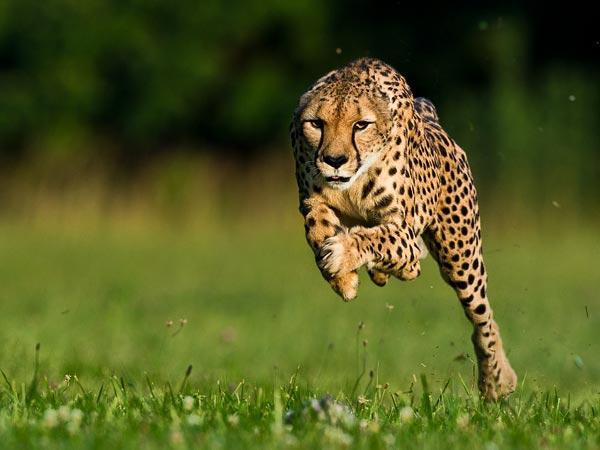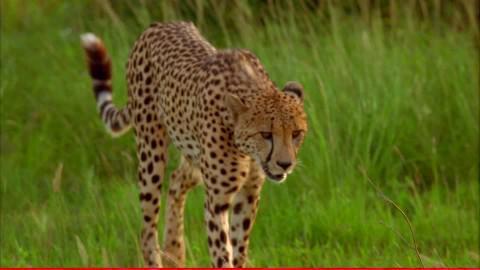The first image is the image on the left, the second image is the image on the right. For the images shown, is this caption "An image shows one running cheetah with front paws off the ground." true? Answer yes or no. Yes. 